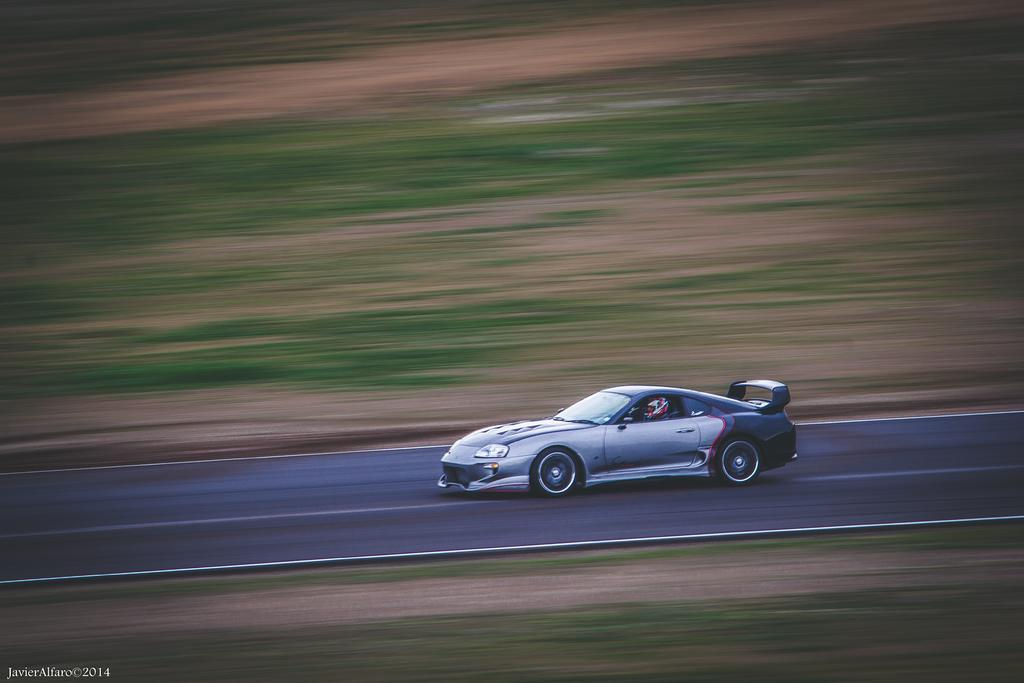What type of terrain is visible in the image? There is grass in the image. What is the person in the image doing? There is a person driving a car in the image. What kind of track is visible in the image? There is a racing track in the image. What information is provided at the bottom of the image? There is text at the bottom of the image. What type of paper is being used as a stage in the image? There is no paper or stage present in the image. How many cards are visible on the racing track in the image? There are no cards visible on the racing track in the image. 